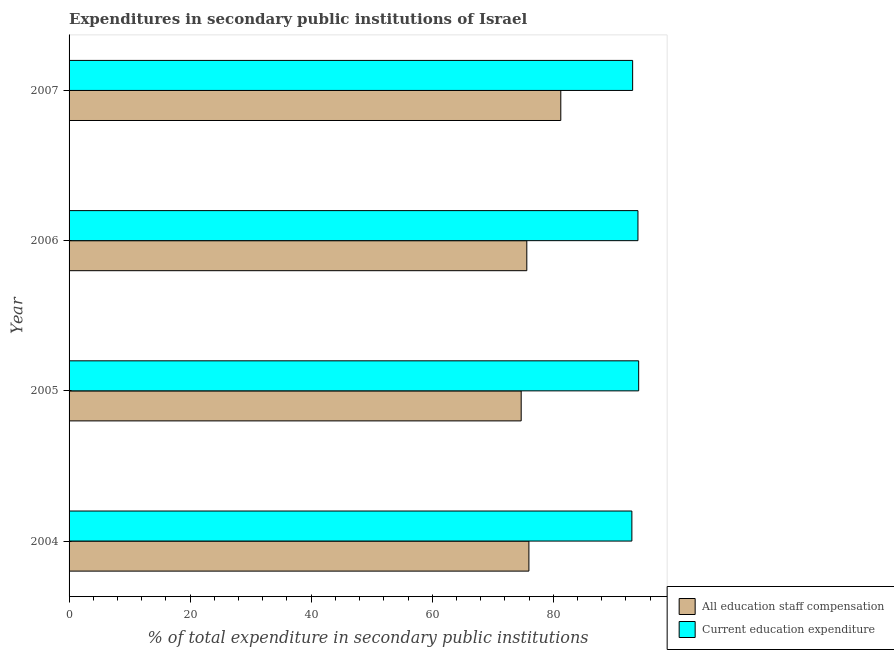How many different coloured bars are there?
Your response must be concise. 2. How many groups of bars are there?
Provide a succinct answer. 4. Are the number of bars on each tick of the Y-axis equal?
Provide a short and direct response. Yes. How many bars are there on the 3rd tick from the bottom?
Your answer should be compact. 2. What is the label of the 4th group of bars from the top?
Your response must be concise. 2004. What is the expenditure in staff compensation in 2004?
Make the answer very short. 75.97. Across all years, what is the maximum expenditure in staff compensation?
Ensure brevity in your answer.  81.24. Across all years, what is the minimum expenditure in education?
Keep it short and to the point. 92.99. What is the total expenditure in staff compensation in the graph?
Keep it short and to the point. 307.54. What is the difference between the expenditure in staff compensation in 2005 and that in 2006?
Keep it short and to the point. -0.93. What is the difference between the expenditure in education in 2006 and the expenditure in staff compensation in 2007?
Your response must be concise. 12.75. What is the average expenditure in staff compensation per year?
Offer a terse response. 76.89. In the year 2004, what is the difference between the expenditure in education and expenditure in staff compensation?
Your response must be concise. 17.01. Is the expenditure in staff compensation in 2005 less than that in 2006?
Provide a short and direct response. Yes. Is the difference between the expenditure in staff compensation in 2005 and 2006 greater than the difference between the expenditure in education in 2005 and 2006?
Offer a very short reply. No. What is the difference between the highest and the second highest expenditure in staff compensation?
Keep it short and to the point. 5.27. What is the difference between the highest and the lowest expenditure in staff compensation?
Your answer should be compact. 6.54. In how many years, is the expenditure in education greater than the average expenditure in education taken over all years?
Provide a short and direct response. 2. Is the sum of the expenditure in staff compensation in 2004 and 2005 greater than the maximum expenditure in education across all years?
Your answer should be very brief. Yes. What does the 2nd bar from the top in 2007 represents?
Offer a terse response. All education staff compensation. What does the 1st bar from the bottom in 2007 represents?
Your response must be concise. All education staff compensation. How many bars are there?
Make the answer very short. 8. Are all the bars in the graph horizontal?
Keep it short and to the point. Yes. How many years are there in the graph?
Provide a short and direct response. 4. What is the difference between two consecutive major ticks on the X-axis?
Offer a very short reply. 20. Are the values on the major ticks of X-axis written in scientific E-notation?
Provide a succinct answer. No. Where does the legend appear in the graph?
Ensure brevity in your answer.  Bottom right. How many legend labels are there?
Your response must be concise. 2. How are the legend labels stacked?
Provide a short and direct response. Vertical. What is the title of the graph?
Offer a very short reply. Expenditures in secondary public institutions of Israel. Does "Nonresident" appear as one of the legend labels in the graph?
Provide a succinct answer. No. What is the label or title of the X-axis?
Your response must be concise. % of total expenditure in secondary public institutions. What is the label or title of the Y-axis?
Make the answer very short. Year. What is the % of total expenditure in secondary public institutions in All education staff compensation in 2004?
Keep it short and to the point. 75.97. What is the % of total expenditure in secondary public institutions in Current education expenditure in 2004?
Ensure brevity in your answer.  92.99. What is the % of total expenditure in secondary public institutions in All education staff compensation in 2005?
Your response must be concise. 74.7. What is the % of total expenditure in secondary public institutions in Current education expenditure in 2005?
Offer a terse response. 94.11. What is the % of total expenditure in secondary public institutions in All education staff compensation in 2006?
Give a very brief answer. 75.63. What is the % of total expenditure in secondary public institutions of Current education expenditure in 2006?
Provide a succinct answer. 93.99. What is the % of total expenditure in secondary public institutions of All education staff compensation in 2007?
Your answer should be compact. 81.24. What is the % of total expenditure in secondary public institutions in Current education expenditure in 2007?
Your response must be concise. 93.11. Across all years, what is the maximum % of total expenditure in secondary public institutions in All education staff compensation?
Ensure brevity in your answer.  81.24. Across all years, what is the maximum % of total expenditure in secondary public institutions in Current education expenditure?
Your answer should be very brief. 94.11. Across all years, what is the minimum % of total expenditure in secondary public institutions in All education staff compensation?
Provide a short and direct response. 74.7. Across all years, what is the minimum % of total expenditure in secondary public institutions of Current education expenditure?
Offer a very short reply. 92.99. What is the total % of total expenditure in secondary public institutions of All education staff compensation in the graph?
Your answer should be compact. 307.54. What is the total % of total expenditure in secondary public institutions in Current education expenditure in the graph?
Your response must be concise. 374.2. What is the difference between the % of total expenditure in secondary public institutions of All education staff compensation in 2004 and that in 2005?
Ensure brevity in your answer.  1.28. What is the difference between the % of total expenditure in secondary public institutions of Current education expenditure in 2004 and that in 2005?
Make the answer very short. -1.12. What is the difference between the % of total expenditure in secondary public institutions of All education staff compensation in 2004 and that in 2006?
Make the answer very short. 0.35. What is the difference between the % of total expenditure in secondary public institutions in Current education expenditure in 2004 and that in 2006?
Provide a short and direct response. -1. What is the difference between the % of total expenditure in secondary public institutions of All education staff compensation in 2004 and that in 2007?
Give a very brief answer. -5.27. What is the difference between the % of total expenditure in secondary public institutions of Current education expenditure in 2004 and that in 2007?
Offer a very short reply. -0.12. What is the difference between the % of total expenditure in secondary public institutions in All education staff compensation in 2005 and that in 2006?
Your answer should be compact. -0.93. What is the difference between the % of total expenditure in secondary public institutions of Current education expenditure in 2005 and that in 2006?
Offer a very short reply. 0.12. What is the difference between the % of total expenditure in secondary public institutions in All education staff compensation in 2005 and that in 2007?
Your answer should be compact. -6.54. What is the difference between the % of total expenditure in secondary public institutions in All education staff compensation in 2006 and that in 2007?
Offer a terse response. -5.61. What is the difference between the % of total expenditure in secondary public institutions of Current education expenditure in 2006 and that in 2007?
Your answer should be compact. 0.88. What is the difference between the % of total expenditure in secondary public institutions of All education staff compensation in 2004 and the % of total expenditure in secondary public institutions of Current education expenditure in 2005?
Offer a terse response. -18.14. What is the difference between the % of total expenditure in secondary public institutions of All education staff compensation in 2004 and the % of total expenditure in secondary public institutions of Current education expenditure in 2006?
Your answer should be compact. -18.02. What is the difference between the % of total expenditure in secondary public institutions of All education staff compensation in 2004 and the % of total expenditure in secondary public institutions of Current education expenditure in 2007?
Your answer should be compact. -17.14. What is the difference between the % of total expenditure in secondary public institutions of All education staff compensation in 2005 and the % of total expenditure in secondary public institutions of Current education expenditure in 2006?
Offer a terse response. -19.29. What is the difference between the % of total expenditure in secondary public institutions of All education staff compensation in 2005 and the % of total expenditure in secondary public institutions of Current education expenditure in 2007?
Your response must be concise. -18.41. What is the difference between the % of total expenditure in secondary public institutions of All education staff compensation in 2006 and the % of total expenditure in secondary public institutions of Current education expenditure in 2007?
Provide a succinct answer. -17.48. What is the average % of total expenditure in secondary public institutions in All education staff compensation per year?
Make the answer very short. 76.89. What is the average % of total expenditure in secondary public institutions in Current education expenditure per year?
Your response must be concise. 93.55. In the year 2004, what is the difference between the % of total expenditure in secondary public institutions in All education staff compensation and % of total expenditure in secondary public institutions in Current education expenditure?
Provide a succinct answer. -17.01. In the year 2005, what is the difference between the % of total expenditure in secondary public institutions in All education staff compensation and % of total expenditure in secondary public institutions in Current education expenditure?
Provide a succinct answer. -19.41. In the year 2006, what is the difference between the % of total expenditure in secondary public institutions of All education staff compensation and % of total expenditure in secondary public institutions of Current education expenditure?
Give a very brief answer. -18.36. In the year 2007, what is the difference between the % of total expenditure in secondary public institutions in All education staff compensation and % of total expenditure in secondary public institutions in Current education expenditure?
Ensure brevity in your answer.  -11.87. What is the ratio of the % of total expenditure in secondary public institutions of All education staff compensation in 2004 to that in 2005?
Your answer should be compact. 1.02. What is the ratio of the % of total expenditure in secondary public institutions of Current education expenditure in 2004 to that in 2006?
Ensure brevity in your answer.  0.99. What is the ratio of the % of total expenditure in secondary public institutions of All education staff compensation in 2004 to that in 2007?
Your response must be concise. 0.94. What is the ratio of the % of total expenditure in secondary public institutions of Current education expenditure in 2004 to that in 2007?
Provide a short and direct response. 1. What is the ratio of the % of total expenditure in secondary public institutions in Current education expenditure in 2005 to that in 2006?
Provide a succinct answer. 1. What is the ratio of the % of total expenditure in secondary public institutions in All education staff compensation in 2005 to that in 2007?
Give a very brief answer. 0.92. What is the ratio of the % of total expenditure in secondary public institutions in Current education expenditure in 2005 to that in 2007?
Provide a short and direct response. 1.01. What is the ratio of the % of total expenditure in secondary public institutions of All education staff compensation in 2006 to that in 2007?
Provide a short and direct response. 0.93. What is the ratio of the % of total expenditure in secondary public institutions in Current education expenditure in 2006 to that in 2007?
Your response must be concise. 1.01. What is the difference between the highest and the second highest % of total expenditure in secondary public institutions in All education staff compensation?
Provide a short and direct response. 5.27. What is the difference between the highest and the second highest % of total expenditure in secondary public institutions of Current education expenditure?
Your response must be concise. 0.12. What is the difference between the highest and the lowest % of total expenditure in secondary public institutions in All education staff compensation?
Your response must be concise. 6.54. What is the difference between the highest and the lowest % of total expenditure in secondary public institutions in Current education expenditure?
Offer a very short reply. 1.12. 